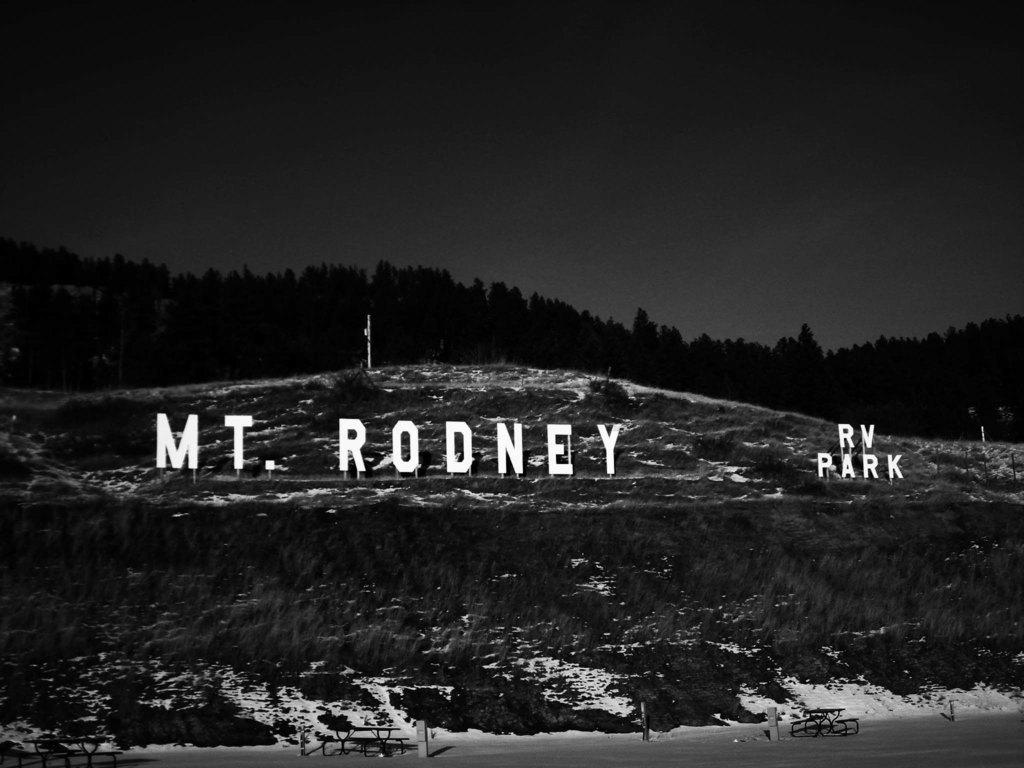What is the name of the rv park?
Offer a very short reply. Mt. rodney. 